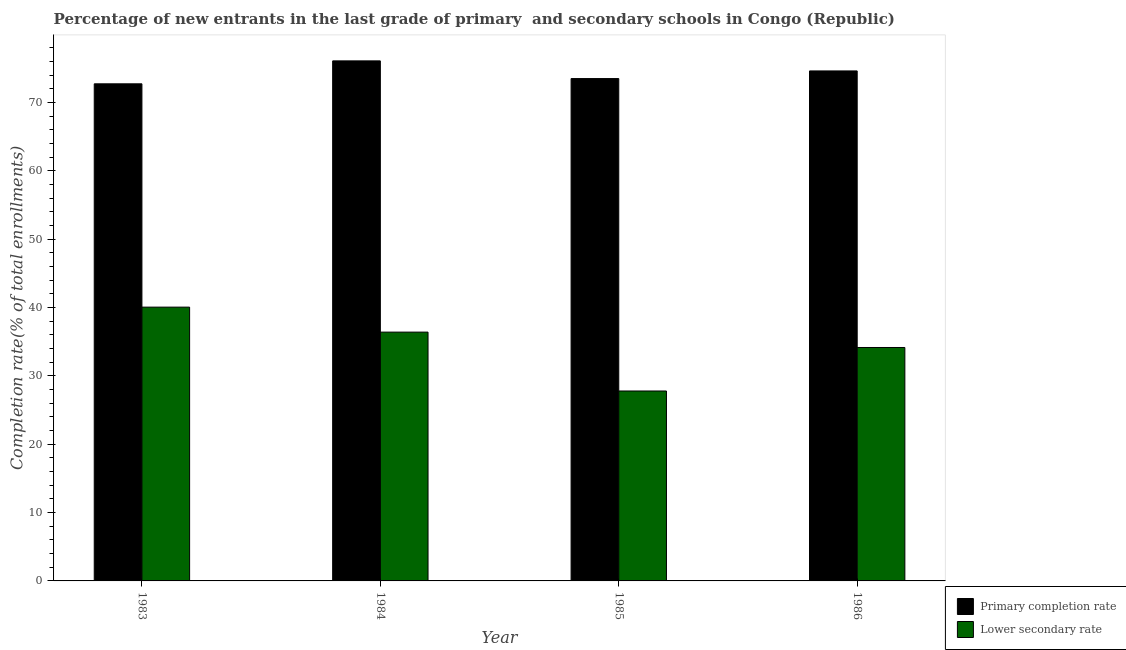How many groups of bars are there?
Keep it short and to the point. 4. How many bars are there on the 3rd tick from the right?
Make the answer very short. 2. What is the label of the 1st group of bars from the left?
Make the answer very short. 1983. What is the completion rate in primary schools in 1985?
Give a very brief answer. 73.48. Across all years, what is the maximum completion rate in primary schools?
Offer a terse response. 76.07. Across all years, what is the minimum completion rate in primary schools?
Your response must be concise. 72.72. In which year was the completion rate in primary schools maximum?
Keep it short and to the point. 1984. What is the total completion rate in primary schools in the graph?
Ensure brevity in your answer.  296.87. What is the difference between the completion rate in primary schools in 1984 and that in 1985?
Provide a short and direct response. 2.59. What is the difference between the completion rate in secondary schools in 1984 and the completion rate in primary schools in 1985?
Your response must be concise. 8.61. What is the average completion rate in secondary schools per year?
Your answer should be compact. 34.59. In the year 1986, what is the difference between the completion rate in primary schools and completion rate in secondary schools?
Give a very brief answer. 0. In how many years, is the completion rate in secondary schools greater than 46 %?
Your response must be concise. 0. What is the ratio of the completion rate in primary schools in 1983 to that in 1985?
Ensure brevity in your answer.  0.99. Is the completion rate in secondary schools in 1985 less than that in 1986?
Your response must be concise. Yes. What is the difference between the highest and the second highest completion rate in secondary schools?
Your answer should be very brief. 3.66. What is the difference between the highest and the lowest completion rate in secondary schools?
Offer a terse response. 12.27. What does the 1st bar from the left in 1984 represents?
Make the answer very short. Primary completion rate. What does the 1st bar from the right in 1986 represents?
Your response must be concise. Lower secondary rate. How many bars are there?
Provide a succinct answer. 8. Are all the bars in the graph horizontal?
Offer a terse response. No. How many years are there in the graph?
Your answer should be compact. 4. Are the values on the major ticks of Y-axis written in scientific E-notation?
Your answer should be compact. No. Does the graph contain any zero values?
Provide a succinct answer. No. What is the title of the graph?
Your answer should be very brief. Percentage of new entrants in the last grade of primary  and secondary schools in Congo (Republic). What is the label or title of the X-axis?
Offer a very short reply. Year. What is the label or title of the Y-axis?
Your answer should be compact. Completion rate(% of total enrollments). What is the Completion rate(% of total enrollments) in Primary completion rate in 1983?
Your answer should be very brief. 72.72. What is the Completion rate(% of total enrollments) of Lower secondary rate in 1983?
Offer a terse response. 40.05. What is the Completion rate(% of total enrollments) of Primary completion rate in 1984?
Your response must be concise. 76.07. What is the Completion rate(% of total enrollments) in Lower secondary rate in 1984?
Offer a terse response. 36.39. What is the Completion rate(% of total enrollments) of Primary completion rate in 1985?
Offer a very short reply. 73.48. What is the Completion rate(% of total enrollments) in Lower secondary rate in 1985?
Your answer should be very brief. 27.78. What is the Completion rate(% of total enrollments) in Primary completion rate in 1986?
Your answer should be compact. 74.6. What is the Completion rate(% of total enrollments) in Lower secondary rate in 1986?
Make the answer very short. 34.15. Across all years, what is the maximum Completion rate(% of total enrollments) in Primary completion rate?
Provide a short and direct response. 76.07. Across all years, what is the maximum Completion rate(% of total enrollments) in Lower secondary rate?
Give a very brief answer. 40.05. Across all years, what is the minimum Completion rate(% of total enrollments) in Primary completion rate?
Make the answer very short. 72.72. Across all years, what is the minimum Completion rate(% of total enrollments) in Lower secondary rate?
Ensure brevity in your answer.  27.78. What is the total Completion rate(% of total enrollments) in Primary completion rate in the graph?
Your answer should be compact. 296.87. What is the total Completion rate(% of total enrollments) of Lower secondary rate in the graph?
Offer a terse response. 138.37. What is the difference between the Completion rate(% of total enrollments) of Primary completion rate in 1983 and that in 1984?
Your answer should be compact. -3.36. What is the difference between the Completion rate(% of total enrollments) of Lower secondary rate in 1983 and that in 1984?
Give a very brief answer. 3.66. What is the difference between the Completion rate(% of total enrollments) in Primary completion rate in 1983 and that in 1985?
Your answer should be very brief. -0.77. What is the difference between the Completion rate(% of total enrollments) of Lower secondary rate in 1983 and that in 1985?
Give a very brief answer. 12.27. What is the difference between the Completion rate(% of total enrollments) in Primary completion rate in 1983 and that in 1986?
Keep it short and to the point. -1.89. What is the difference between the Completion rate(% of total enrollments) of Lower secondary rate in 1983 and that in 1986?
Keep it short and to the point. 5.91. What is the difference between the Completion rate(% of total enrollments) in Primary completion rate in 1984 and that in 1985?
Offer a very short reply. 2.59. What is the difference between the Completion rate(% of total enrollments) of Lower secondary rate in 1984 and that in 1985?
Provide a short and direct response. 8.61. What is the difference between the Completion rate(% of total enrollments) in Primary completion rate in 1984 and that in 1986?
Your answer should be very brief. 1.47. What is the difference between the Completion rate(% of total enrollments) of Lower secondary rate in 1984 and that in 1986?
Your answer should be compact. 2.25. What is the difference between the Completion rate(% of total enrollments) of Primary completion rate in 1985 and that in 1986?
Provide a short and direct response. -1.12. What is the difference between the Completion rate(% of total enrollments) in Lower secondary rate in 1985 and that in 1986?
Keep it short and to the point. -6.36. What is the difference between the Completion rate(% of total enrollments) of Primary completion rate in 1983 and the Completion rate(% of total enrollments) of Lower secondary rate in 1984?
Your response must be concise. 36.32. What is the difference between the Completion rate(% of total enrollments) in Primary completion rate in 1983 and the Completion rate(% of total enrollments) in Lower secondary rate in 1985?
Provide a succinct answer. 44.93. What is the difference between the Completion rate(% of total enrollments) of Primary completion rate in 1983 and the Completion rate(% of total enrollments) of Lower secondary rate in 1986?
Offer a terse response. 38.57. What is the difference between the Completion rate(% of total enrollments) of Primary completion rate in 1984 and the Completion rate(% of total enrollments) of Lower secondary rate in 1985?
Keep it short and to the point. 48.29. What is the difference between the Completion rate(% of total enrollments) in Primary completion rate in 1984 and the Completion rate(% of total enrollments) in Lower secondary rate in 1986?
Make the answer very short. 41.93. What is the difference between the Completion rate(% of total enrollments) of Primary completion rate in 1985 and the Completion rate(% of total enrollments) of Lower secondary rate in 1986?
Keep it short and to the point. 39.34. What is the average Completion rate(% of total enrollments) in Primary completion rate per year?
Your response must be concise. 74.22. What is the average Completion rate(% of total enrollments) in Lower secondary rate per year?
Ensure brevity in your answer.  34.59. In the year 1983, what is the difference between the Completion rate(% of total enrollments) in Primary completion rate and Completion rate(% of total enrollments) in Lower secondary rate?
Provide a succinct answer. 32.66. In the year 1984, what is the difference between the Completion rate(% of total enrollments) in Primary completion rate and Completion rate(% of total enrollments) in Lower secondary rate?
Offer a very short reply. 39.68. In the year 1985, what is the difference between the Completion rate(% of total enrollments) of Primary completion rate and Completion rate(% of total enrollments) of Lower secondary rate?
Provide a short and direct response. 45.7. In the year 1986, what is the difference between the Completion rate(% of total enrollments) of Primary completion rate and Completion rate(% of total enrollments) of Lower secondary rate?
Ensure brevity in your answer.  40.46. What is the ratio of the Completion rate(% of total enrollments) in Primary completion rate in 1983 to that in 1984?
Your answer should be compact. 0.96. What is the ratio of the Completion rate(% of total enrollments) in Lower secondary rate in 1983 to that in 1984?
Offer a terse response. 1.1. What is the ratio of the Completion rate(% of total enrollments) in Primary completion rate in 1983 to that in 1985?
Give a very brief answer. 0.99. What is the ratio of the Completion rate(% of total enrollments) of Lower secondary rate in 1983 to that in 1985?
Make the answer very short. 1.44. What is the ratio of the Completion rate(% of total enrollments) in Primary completion rate in 1983 to that in 1986?
Provide a short and direct response. 0.97. What is the ratio of the Completion rate(% of total enrollments) in Lower secondary rate in 1983 to that in 1986?
Your answer should be compact. 1.17. What is the ratio of the Completion rate(% of total enrollments) of Primary completion rate in 1984 to that in 1985?
Give a very brief answer. 1.04. What is the ratio of the Completion rate(% of total enrollments) of Lower secondary rate in 1984 to that in 1985?
Offer a terse response. 1.31. What is the ratio of the Completion rate(% of total enrollments) of Primary completion rate in 1984 to that in 1986?
Give a very brief answer. 1.02. What is the ratio of the Completion rate(% of total enrollments) of Lower secondary rate in 1984 to that in 1986?
Offer a very short reply. 1.07. What is the ratio of the Completion rate(% of total enrollments) of Lower secondary rate in 1985 to that in 1986?
Offer a terse response. 0.81. What is the difference between the highest and the second highest Completion rate(% of total enrollments) in Primary completion rate?
Your answer should be compact. 1.47. What is the difference between the highest and the second highest Completion rate(% of total enrollments) of Lower secondary rate?
Give a very brief answer. 3.66. What is the difference between the highest and the lowest Completion rate(% of total enrollments) of Primary completion rate?
Offer a very short reply. 3.36. What is the difference between the highest and the lowest Completion rate(% of total enrollments) in Lower secondary rate?
Ensure brevity in your answer.  12.27. 